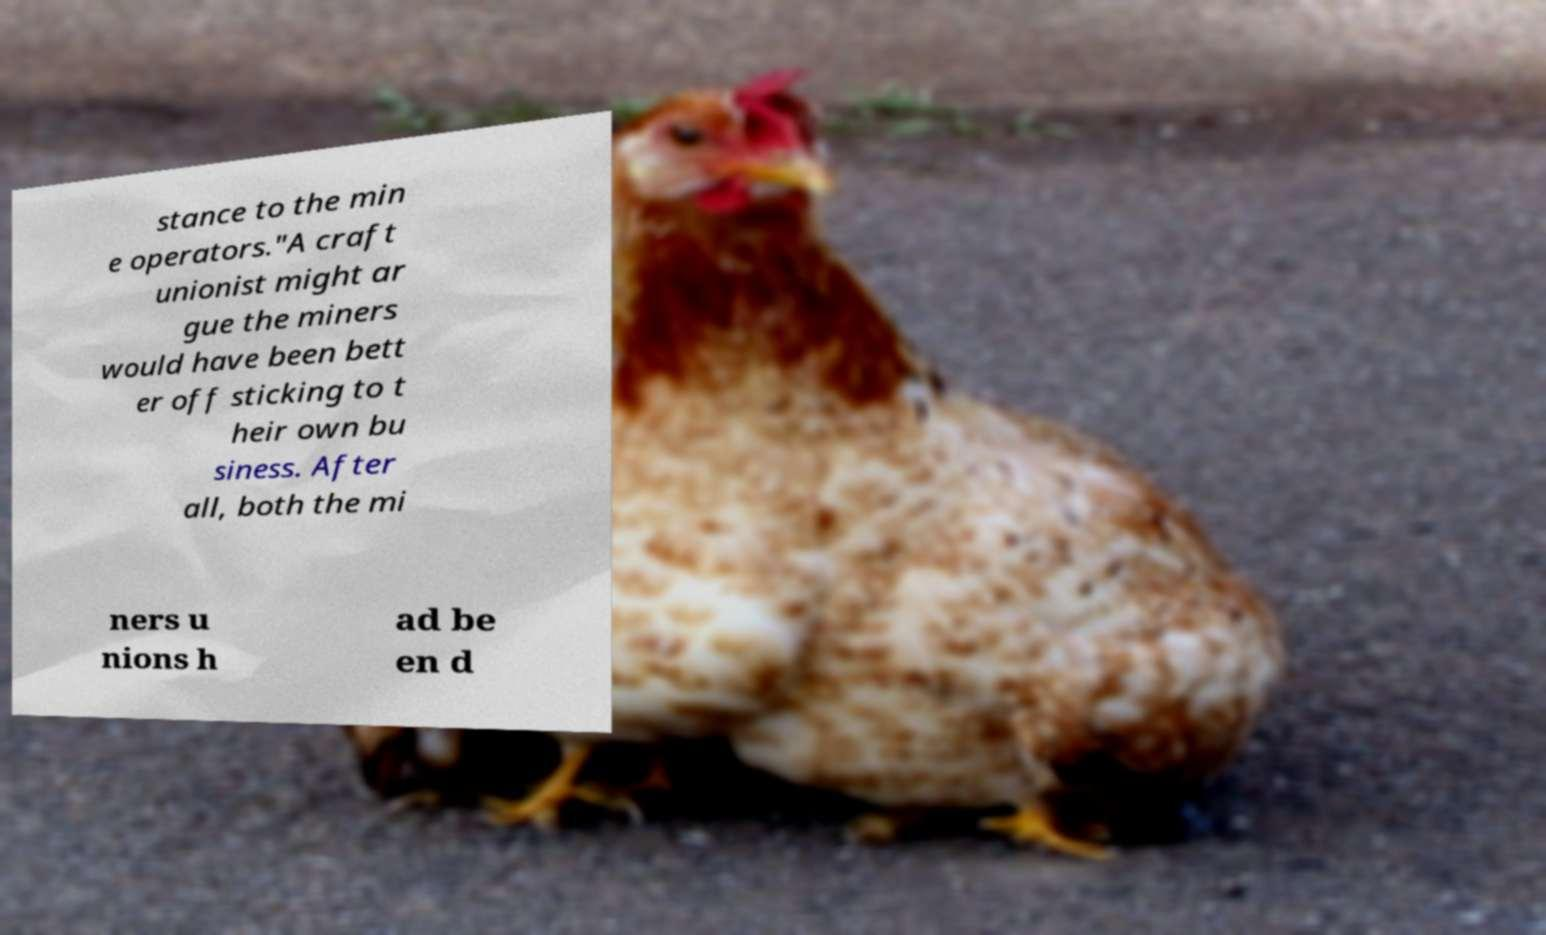Please read and relay the text visible in this image. What does it say? stance to the min e operators."A craft unionist might ar gue the miners would have been bett er off sticking to t heir own bu siness. After all, both the mi ners u nions h ad be en d 